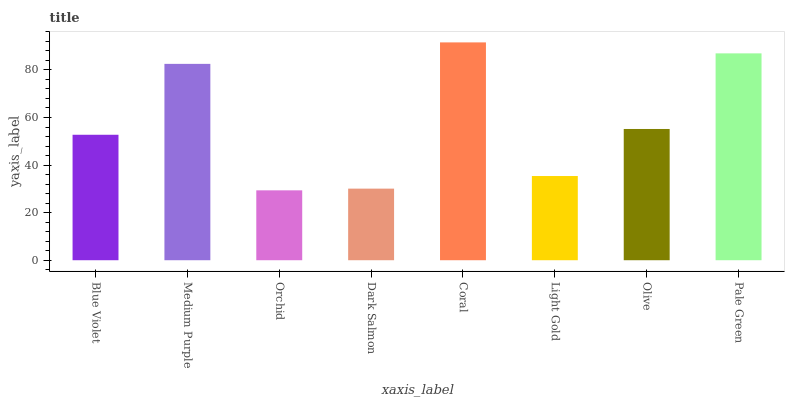Is Orchid the minimum?
Answer yes or no. Yes. Is Coral the maximum?
Answer yes or no. Yes. Is Medium Purple the minimum?
Answer yes or no. No. Is Medium Purple the maximum?
Answer yes or no. No. Is Medium Purple greater than Blue Violet?
Answer yes or no. Yes. Is Blue Violet less than Medium Purple?
Answer yes or no. Yes. Is Blue Violet greater than Medium Purple?
Answer yes or no. No. Is Medium Purple less than Blue Violet?
Answer yes or no. No. Is Olive the high median?
Answer yes or no. Yes. Is Blue Violet the low median?
Answer yes or no. Yes. Is Blue Violet the high median?
Answer yes or no. No. Is Coral the low median?
Answer yes or no. No. 